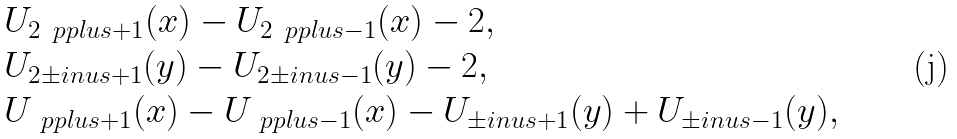Convert formula to latex. <formula><loc_0><loc_0><loc_500><loc_500>& U _ { 2 \ p p l u s + 1 } ( x ) - U _ { 2 \ p p l u s - 1 } ( x ) - 2 , \\ & U _ { 2 \pm i n u s + 1 } ( y ) - U _ { 2 \pm i n u s - 1 } ( y ) - 2 , \\ & U _ { \ p p l u s + 1 } ( x ) - U _ { \ p p l u s - 1 } ( x ) - U _ { \pm i n u s + 1 } ( y ) + U _ { \pm i n u s - 1 } ( y ) ,</formula> 